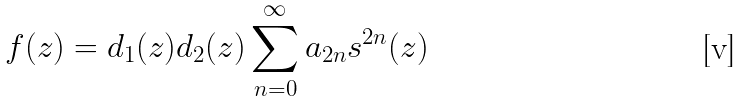Convert formula to latex. <formula><loc_0><loc_0><loc_500><loc_500>f ( z ) = d _ { 1 } ( z ) d _ { 2 } ( z ) \sum _ { n = 0 } ^ { \infty } a _ { 2 n } s ^ { 2 n } ( z )</formula> 